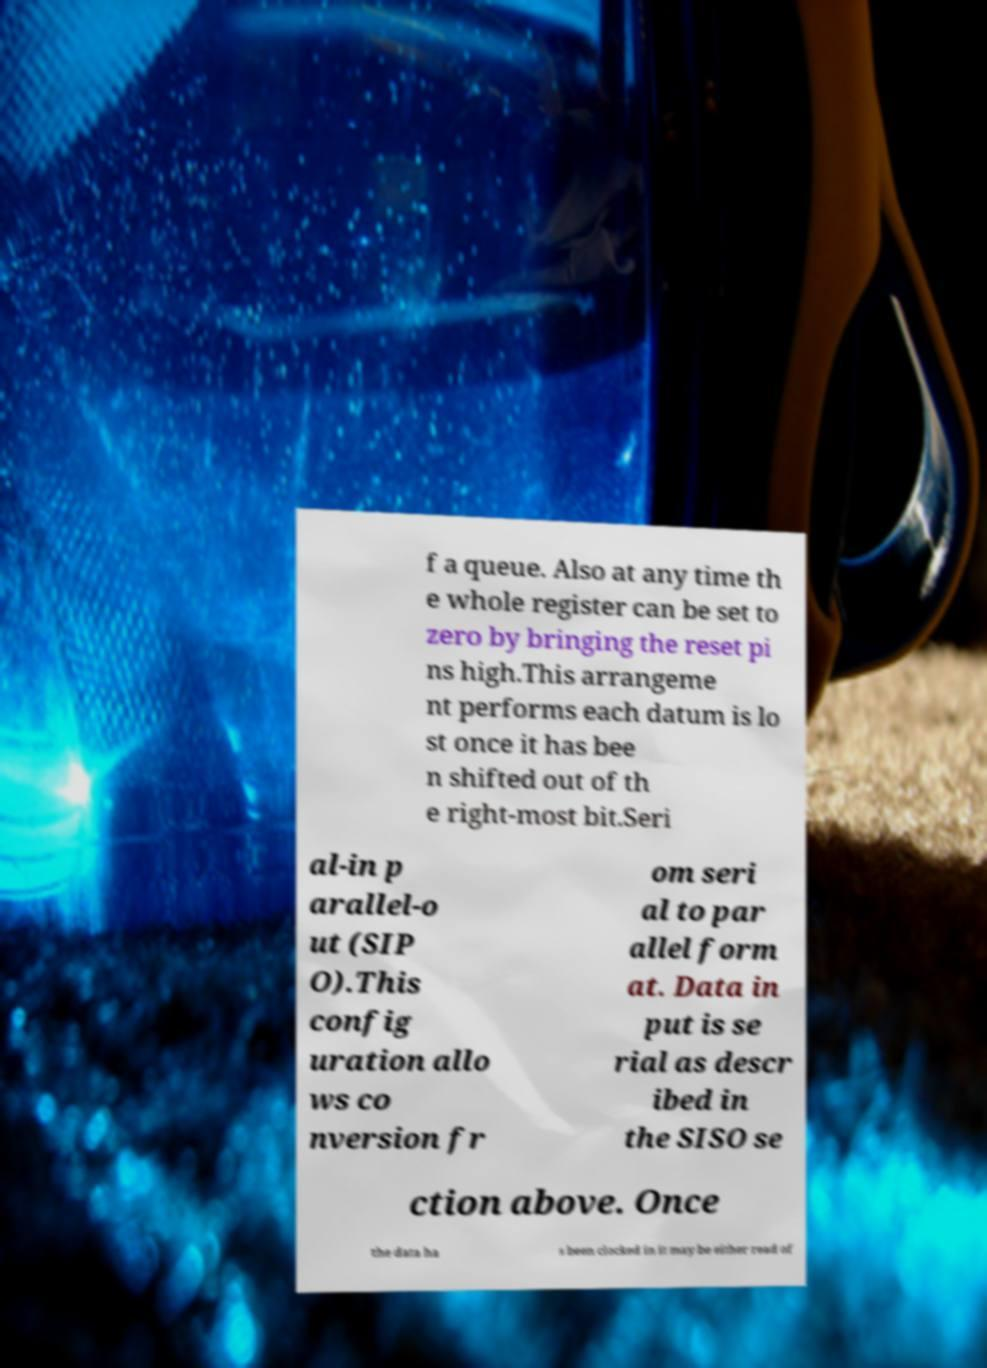What messages or text are displayed in this image? I need them in a readable, typed format. f a queue. Also at any time th e whole register can be set to zero by bringing the reset pi ns high.This arrangeme nt performs each datum is lo st once it has bee n shifted out of th e right-most bit.Seri al-in p arallel-o ut (SIP O).This config uration allo ws co nversion fr om seri al to par allel form at. Data in put is se rial as descr ibed in the SISO se ction above. Once the data ha s been clocked in it may be either read of 